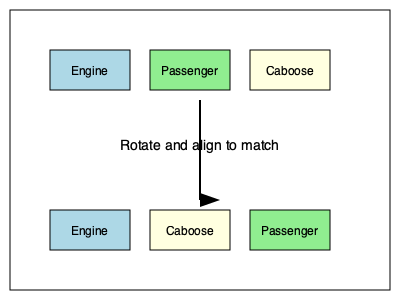A historical train composition in Keenesburg typically follows the order: Engine, Passenger car, Caboose. How many 90-degree rotations are needed to align the bottom train configuration with the correct historical order? To solve this problem, we need to follow these steps:

1. Identify the current order of the bottom train: Engine, Caboose, Passenger car.
2. Compare it to the correct historical order: Engine, Passenger car, Caboose.
3. Determine the number of 90-degree rotations needed to align the cars correctly:

   a. The Engine is already in the correct position, so it doesn't need to be moved.
   b. The Caboose needs to move from the middle to the end, which requires one 90-degree rotation clockwise.
   c. The Passenger car needs to move from the end to the middle, which is achieved by the same rotation that moves the Caboose.

4. Count the total number of 90-degree rotations: 1 rotation is sufficient to achieve the correct order.

This rotation would transform the bottom configuration from "Engine, Caboose, Passenger car" to "Engine, Passenger car, Caboose," matching the historical order of Keenesburg's train compositions.
Answer: 1 rotation 